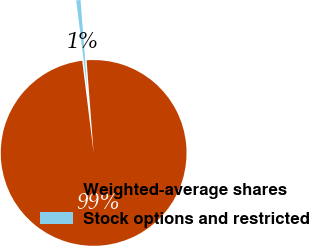Convert chart to OTSL. <chart><loc_0><loc_0><loc_500><loc_500><pie_chart><fcel>Weighted-average shares<fcel>Stock options and restricted<nl><fcel>99.25%<fcel>0.75%<nl></chart> 